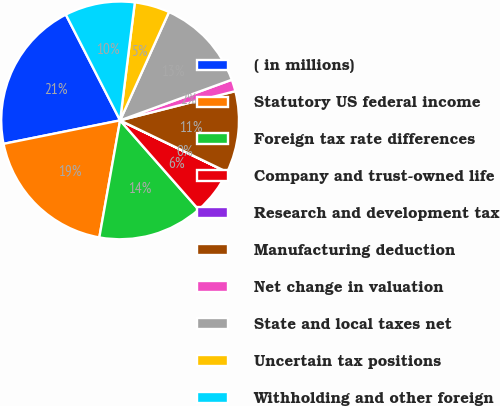Convert chart to OTSL. <chart><loc_0><loc_0><loc_500><loc_500><pie_chart><fcel>( in millions)<fcel>Statutory US federal income<fcel>Foreign tax rate differences<fcel>Company and trust-owned life<fcel>Research and development tax<fcel>Manufacturing deduction<fcel>Net change in valuation<fcel>State and local taxes net<fcel>Uncertain tax positions<fcel>Withholding and other foreign<nl><fcel>20.62%<fcel>19.04%<fcel>14.28%<fcel>6.35%<fcel>0.01%<fcel>11.11%<fcel>1.6%<fcel>12.7%<fcel>4.77%<fcel>9.52%<nl></chart> 